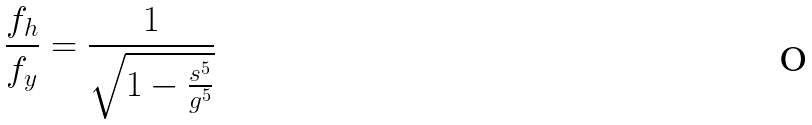<formula> <loc_0><loc_0><loc_500><loc_500>\frac { f _ { h } } { f _ { y } } = \frac { 1 } { \sqrt { 1 - \frac { s ^ { 5 } } { g ^ { 5 } } } }</formula> 